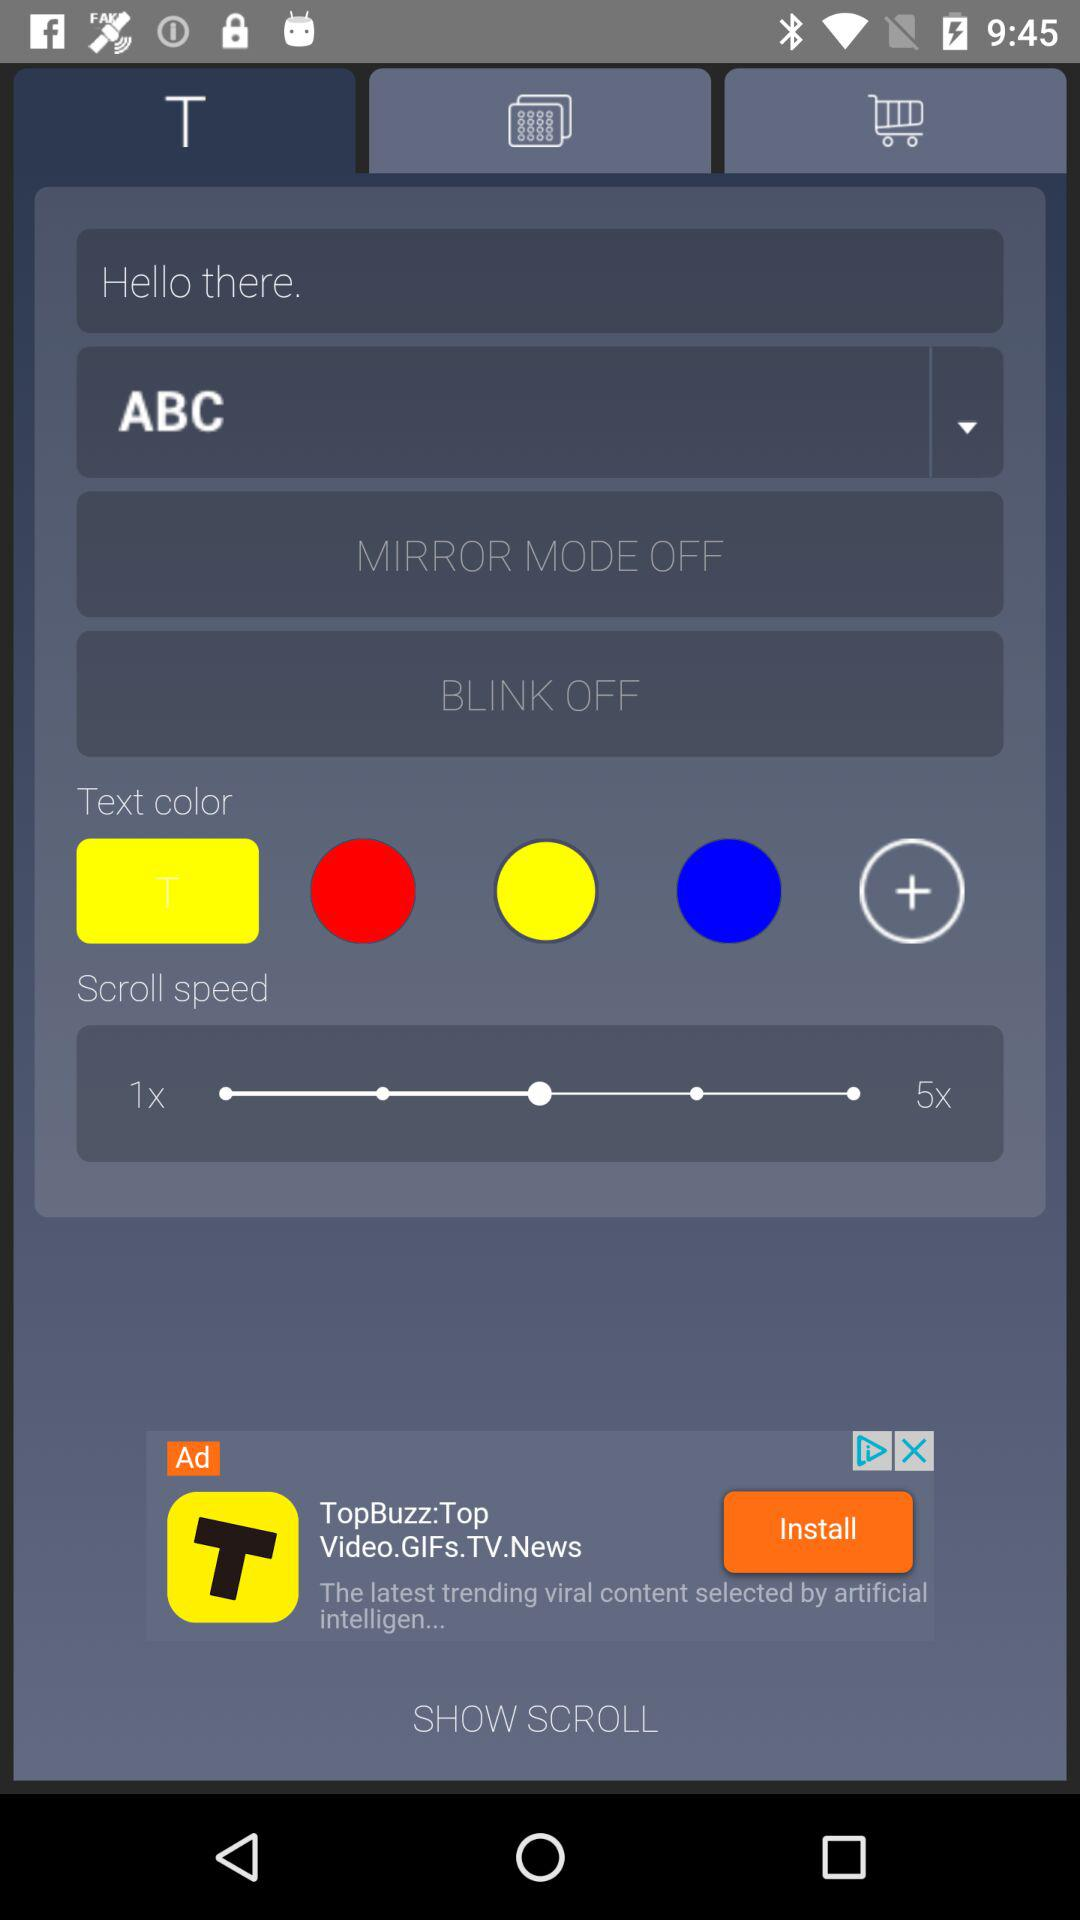What's the status of "Mirror Mode"? The status is "OFF". 